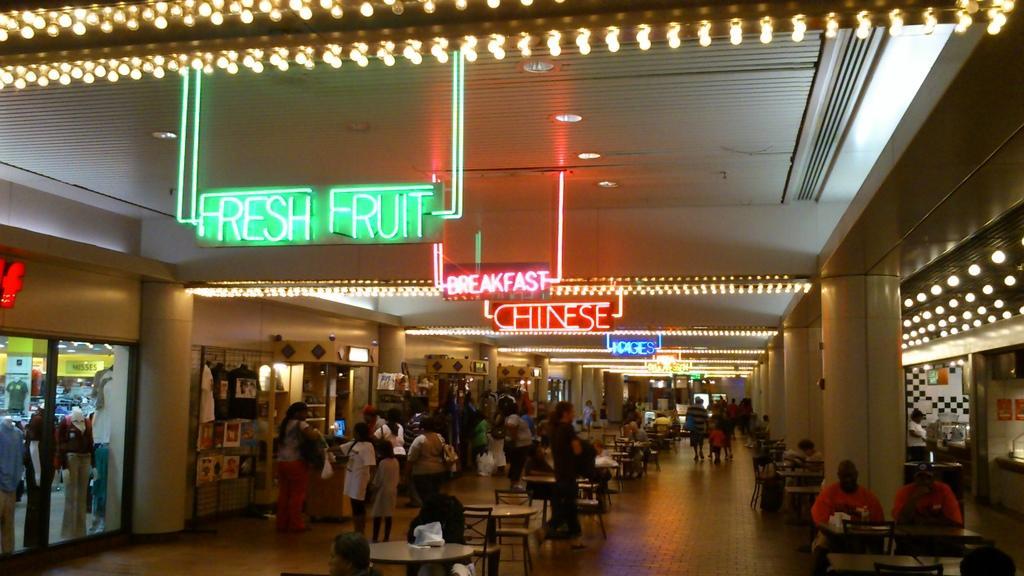Could you give a brief overview of what you see in this image? Here in this picture we can see number of tables and chairs present on the floor and we can also see number of people standing, walking and sitting over the place and beside them on either side we can see pillars and stores present and in the middle we can see hoardings with colorful lights hanging on the roof and we can see lights on the roof. 